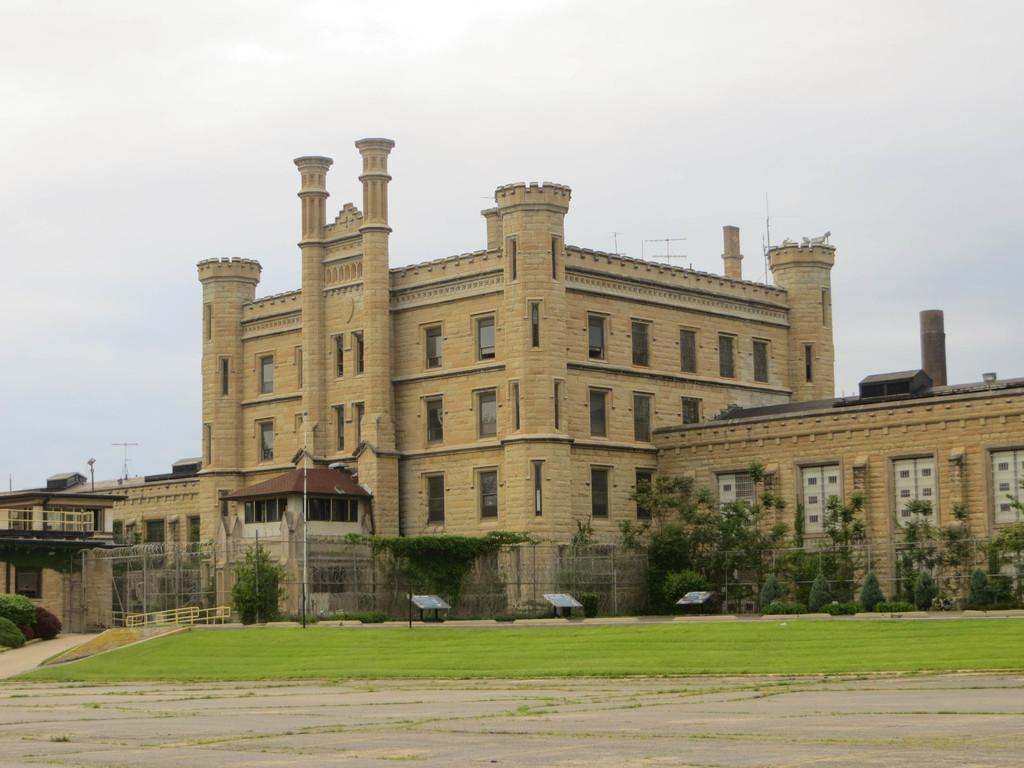What type of structures can be seen in the image? There are buildings with windows in the image. What else is present in the image besides buildings? There are poles and plants visible in the image. What type of vegetation is present in the image? There is grass in the image. What can be seen in the background of the image? The sky is visible in the background of the image. What type of band is playing in the image? There is no band present in the image. How does the earth appear in the image? The image does not show the earth; it shows a scene with buildings, poles, plants, grass, and the sky. 